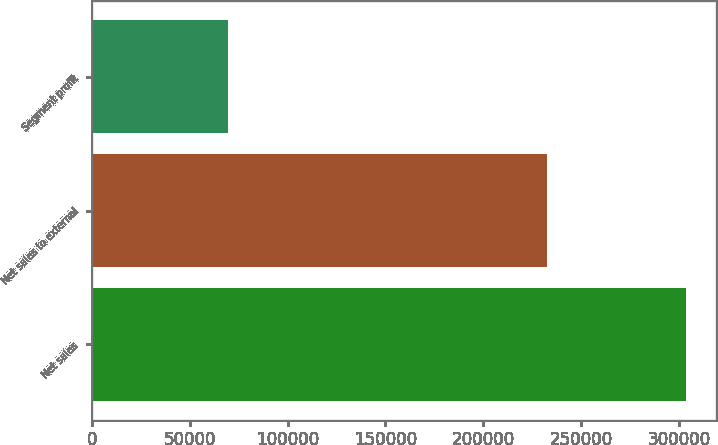Convert chart. <chart><loc_0><loc_0><loc_500><loc_500><bar_chart><fcel>Net sales<fcel>Net sales to external<fcel>Segment profit<nl><fcel>303614<fcel>232643<fcel>69386<nl></chart> 